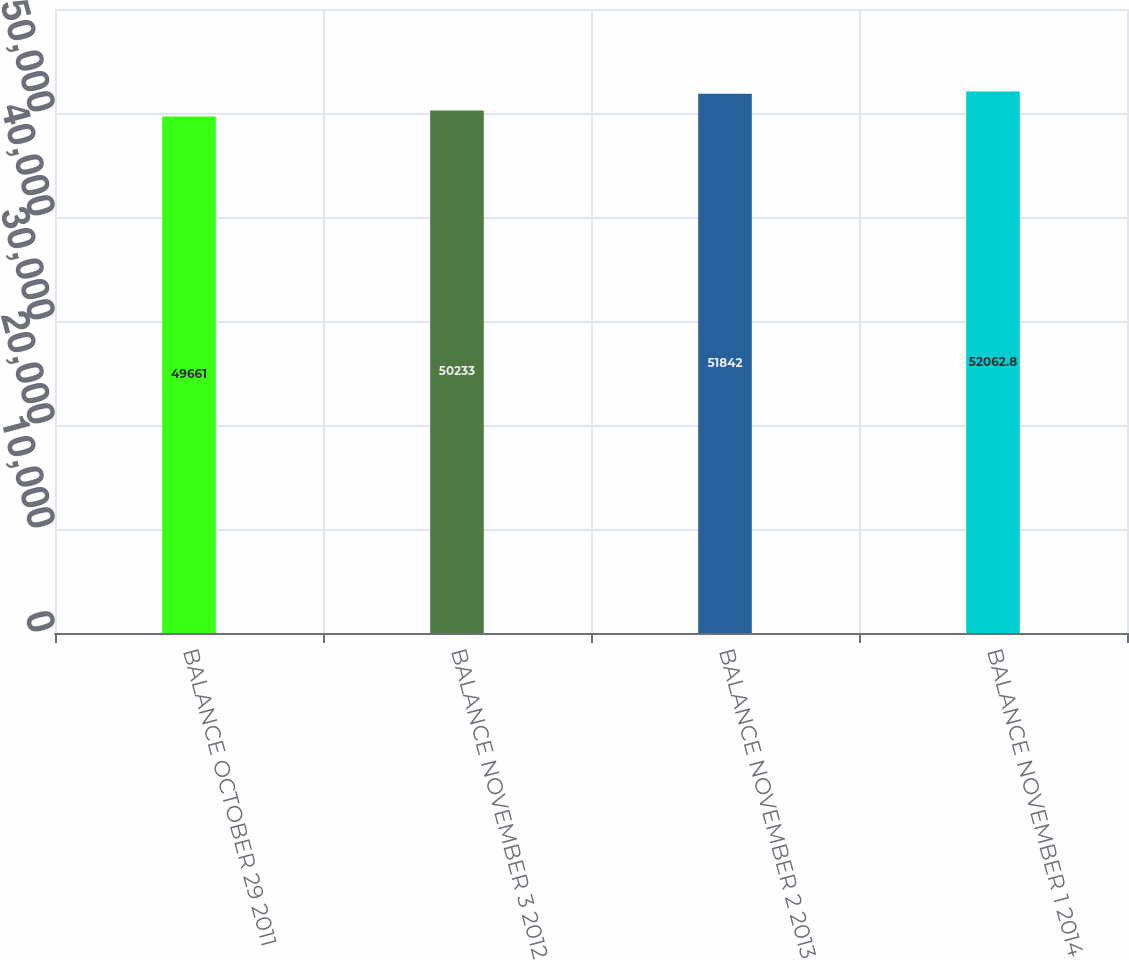<chart> <loc_0><loc_0><loc_500><loc_500><bar_chart><fcel>BALANCE OCTOBER 29 2011<fcel>BALANCE NOVEMBER 3 2012<fcel>BALANCE NOVEMBER 2 2013<fcel>BALANCE NOVEMBER 1 2014<nl><fcel>49661<fcel>50233<fcel>51842<fcel>52062.8<nl></chart> 